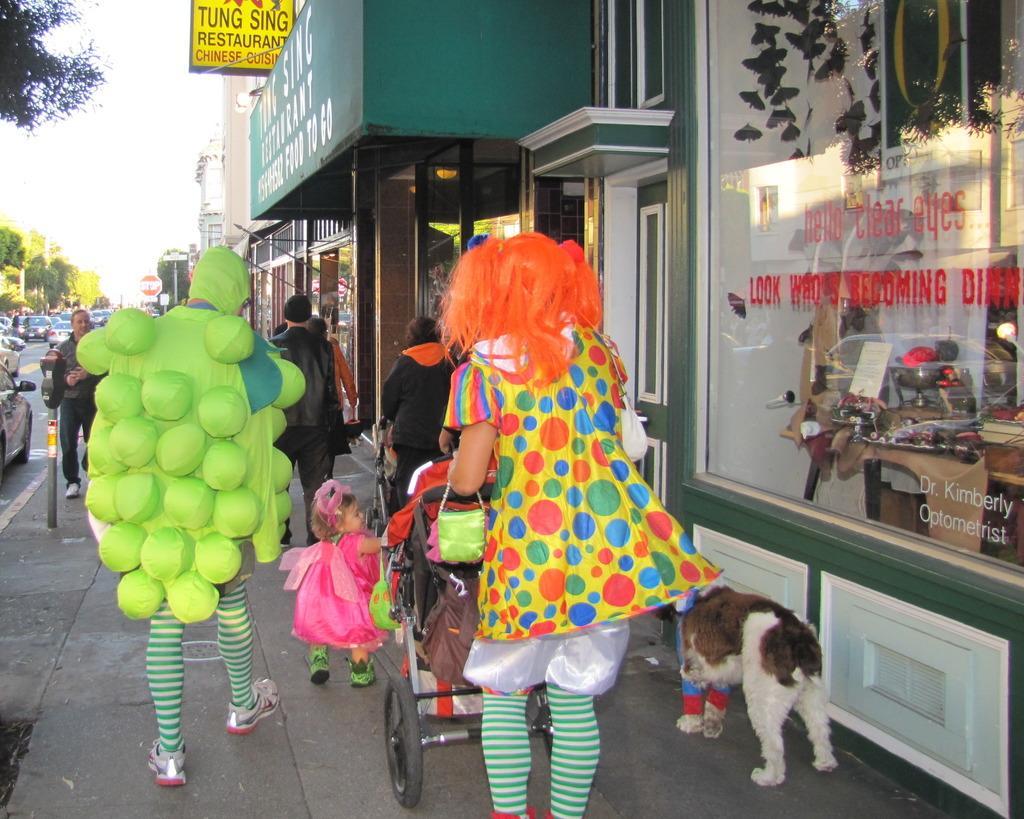In one or two sentences, can you explain what this image depicts? In the picture i can see some group of persons walking through the footpath, i can see a dog, on left side of the image there are some vehicles moving on road, there are some trees, on right side of the image there are some buildings. 